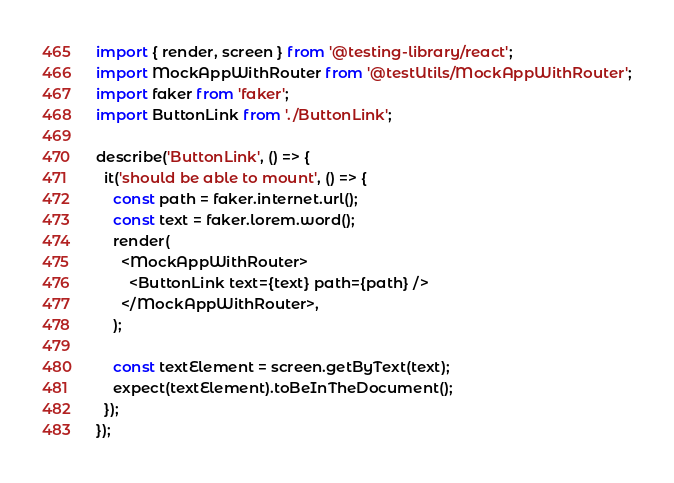<code> <loc_0><loc_0><loc_500><loc_500><_TypeScript_>import { render, screen } from '@testing-library/react';
import MockAppWithRouter from '@testUtils/MockAppWithRouter';
import faker from 'faker';
import ButtonLink from './ButtonLink';

describe('ButtonLink', () => {
  it('should be able to mount', () => {
    const path = faker.internet.url();
    const text = faker.lorem.word();
    render(
      <MockAppWithRouter>
        <ButtonLink text={text} path={path} />
      </MockAppWithRouter>,
    );

    const textElement = screen.getByText(text);
    expect(textElement).toBeInTheDocument();
  });
});
</code> 